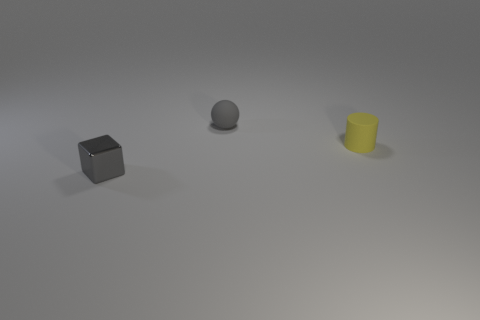What material is the small object that is both in front of the ball and on the left side of the tiny yellow cylinder?
Offer a terse response. Metal. Are there more yellow things that are to the right of the small yellow rubber cylinder than matte objects on the left side of the small gray metal cube?
Ensure brevity in your answer.  No. Are there any other matte cylinders of the same size as the rubber cylinder?
Ensure brevity in your answer.  No. What size is the gray thing that is to the right of the tiny gray object in front of the small gray thing that is behind the small gray metal cube?
Provide a succinct answer. Small. The cube has what color?
Your response must be concise. Gray. Are there more tiny metal blocks that are behind the tiny metal object than large red metallic balls?
Ensure brevity in your answer.  No. There is a tiny gray matte thing; how many tiny things are on the right side of it?
Your answer should be very brief. 1. What shape is the small object that is the same color as the small ball?
Give a very brief answer. Cube. There is a tiny yellow object right of the gray thing that is behind the tiny gray cube; is there a small metal block to the left of it?
Make the answer very short. Yes. Does the matte sphere have the same size as the yellow matte object?
Make the answer very short. Yes. 